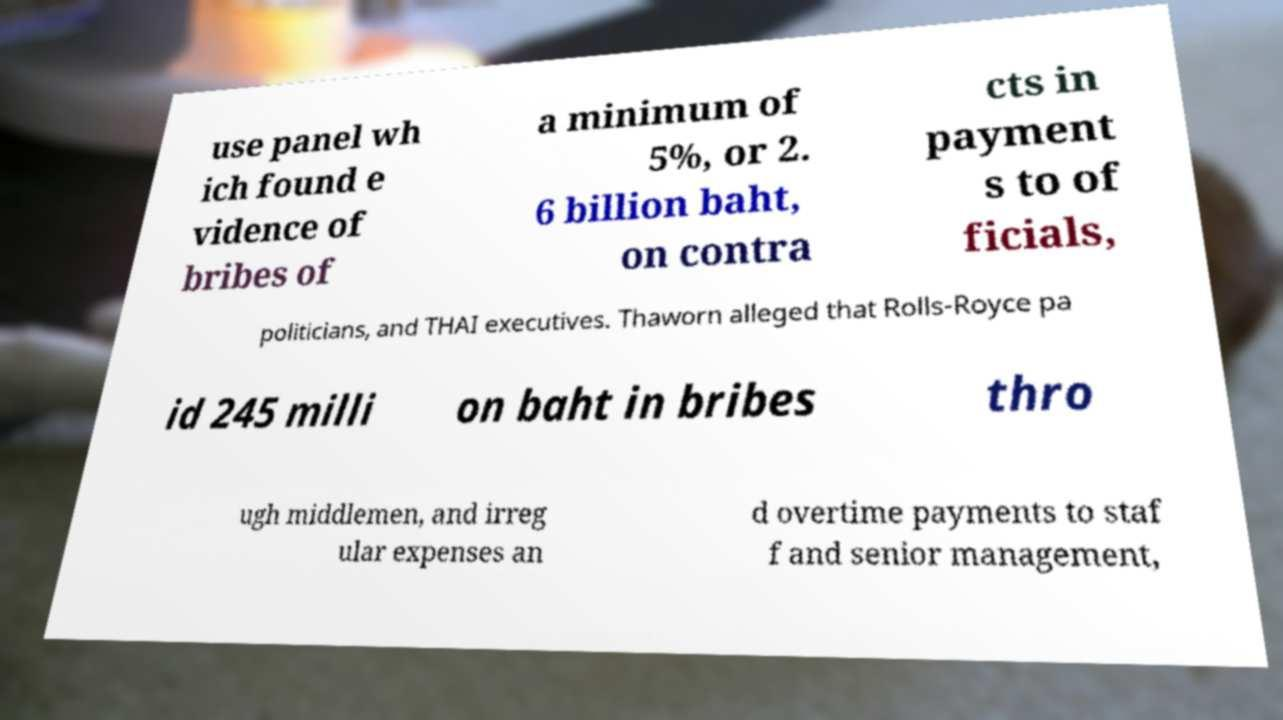Can you read and provide the text displayed in the image?This photo seems to have some interesting text. Can you extract and type it out for me? use panel wh ich found e vidence of bribes of a minimum of 5%, or 2. 6 billion baht, on contra cts in payment s to of ficials, politicians, and THAI executives. Thaworn alleged that Rolls-Royce pa id 245 milli on baht in bribes thro ugh middlemen, and irreg ular expenses an d overtime payments to staf f and senior management, 